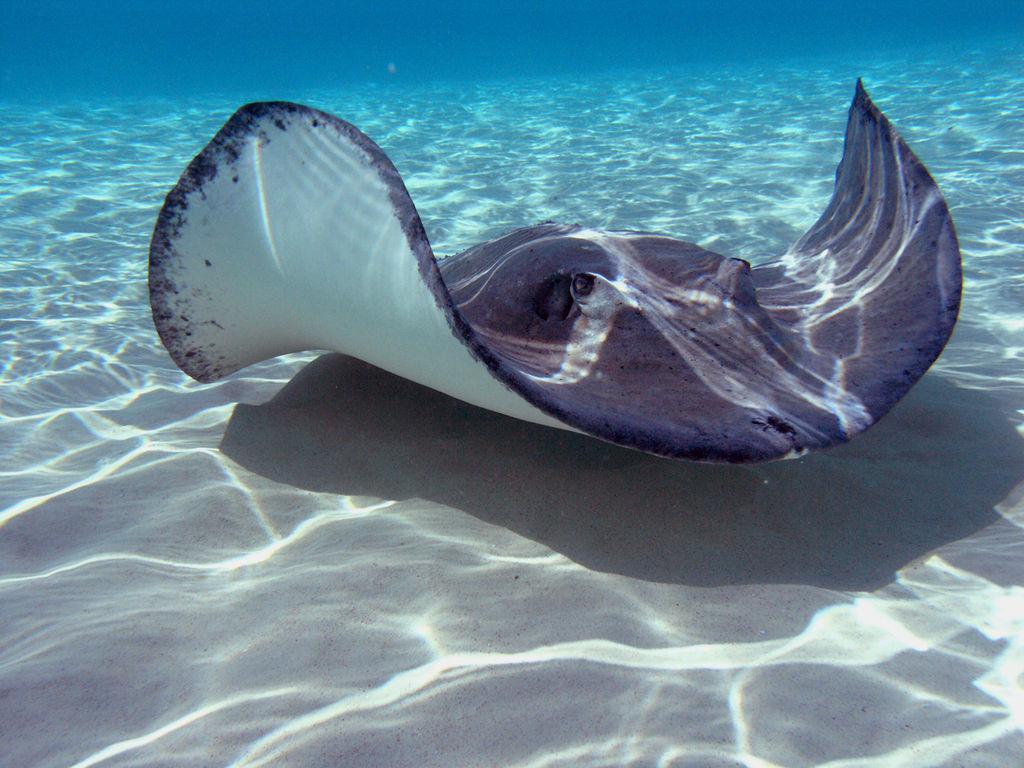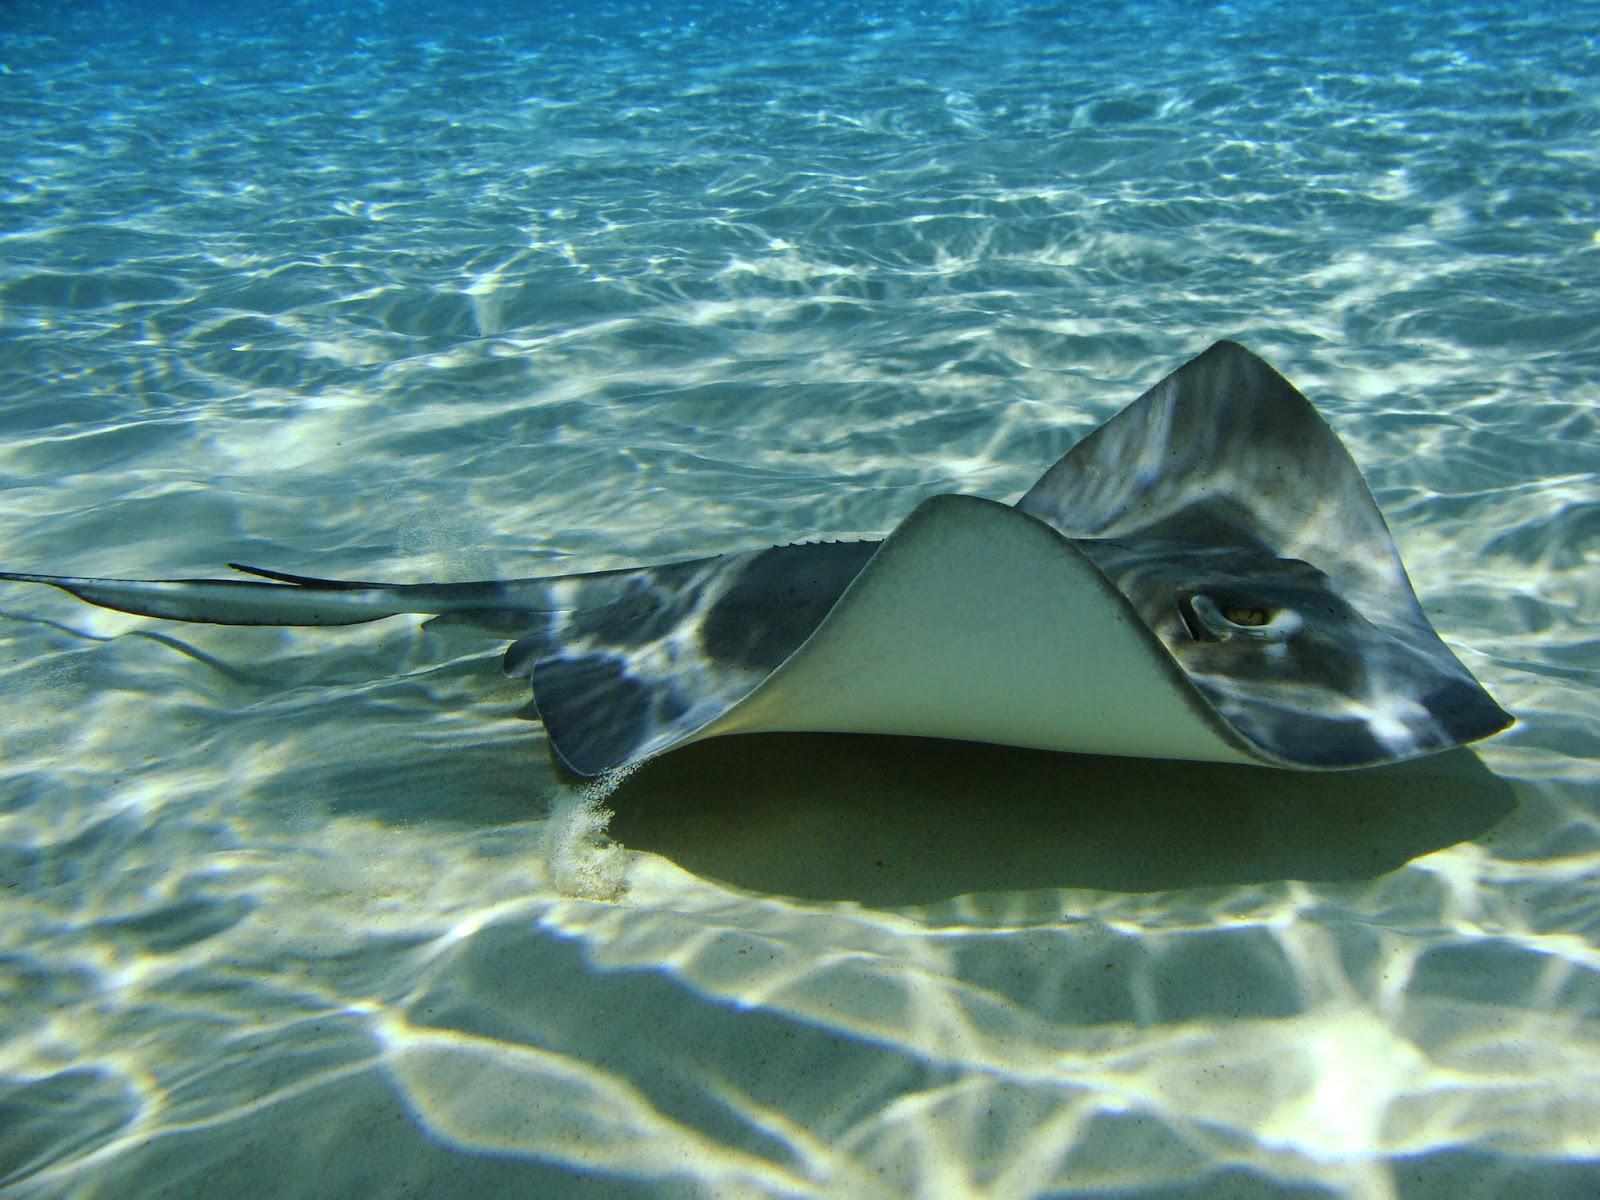The first image is the image on the left, the second image is the image on the right. Evaluate the accuracy of this statement regarding the images: "One image shows the underbelly of a stingray in the foreground, and the other shows the top view of a dark blue stingray without distinctive spots.". Is it true? Answer yes or no. No. The first image is the image on the left, the second image is the image on the right. Assess this claim about the two images: "The stingray on the right image is touching sand.". Correct or not? Answer yes or no. Yes. 